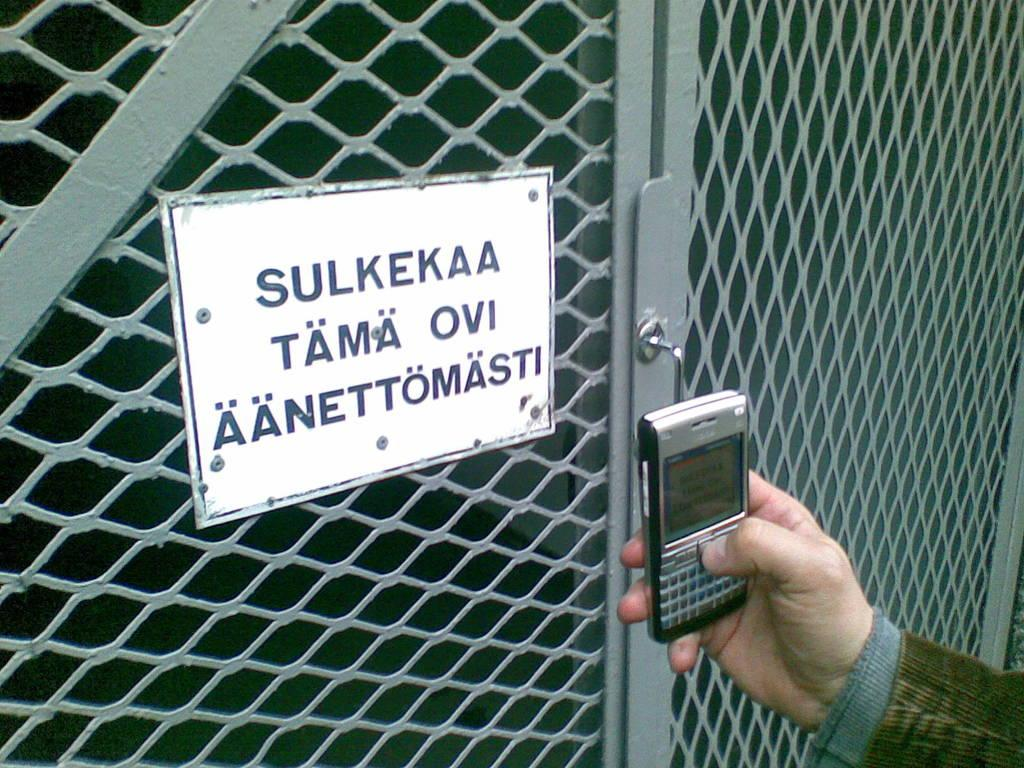What is attached to the door in the image? There is a board on the door in the image. Can you describe the hand and phone in the image? There is a hand holding a phone in the bottom right of the image. What type of cap is the creator wearing in the image? There is no creator or cap present in the image. The image only shows a board on the door and a hand holding a phone. 